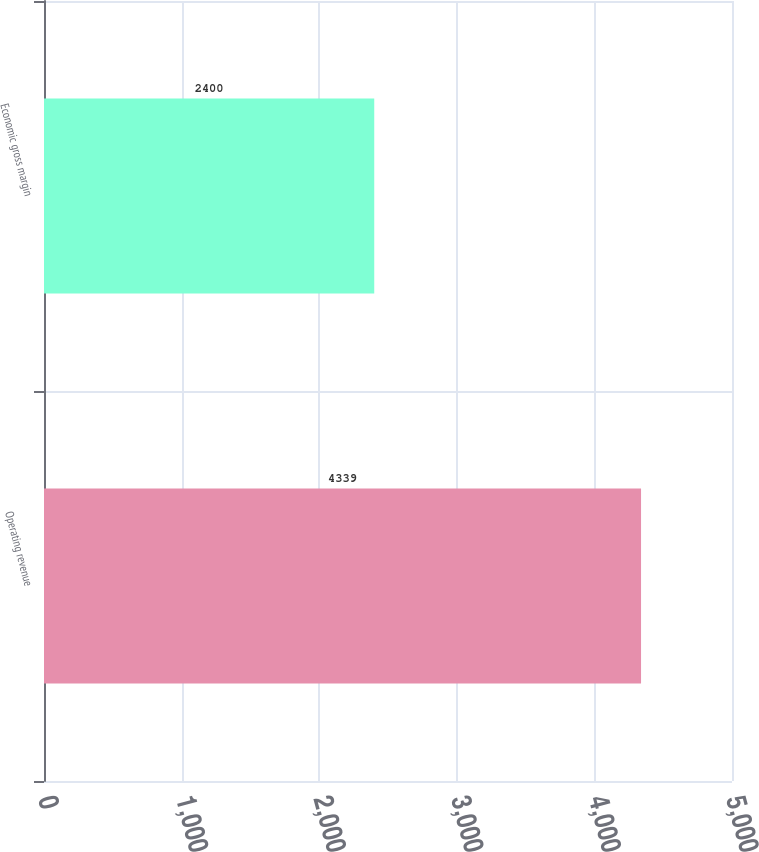Convert chart. <chart><loc_0><loc_0><loc_500><loc_500><bar_chart><fcel>Operating revenue<fcel>Economic gross margin<nl><fcel>4339<fcel>2400<nl></chart> 